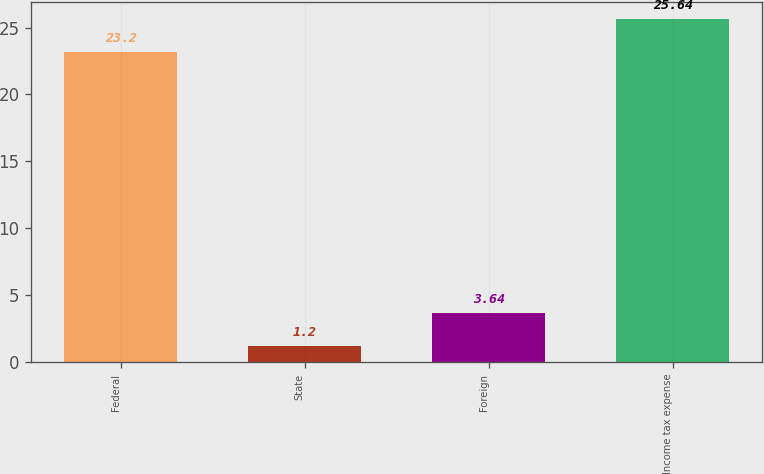Convert chart to OTSL. <chart><loc_0><loc_0><loc_500><loc_500><bar_chart><fcel>Federal<fcel>State<fcel>Foreign<fcel>Income tax expense<nl><fcel>23.2<fcel>1.2<fcel>3.64<fcel>25.64<nl></chart> 